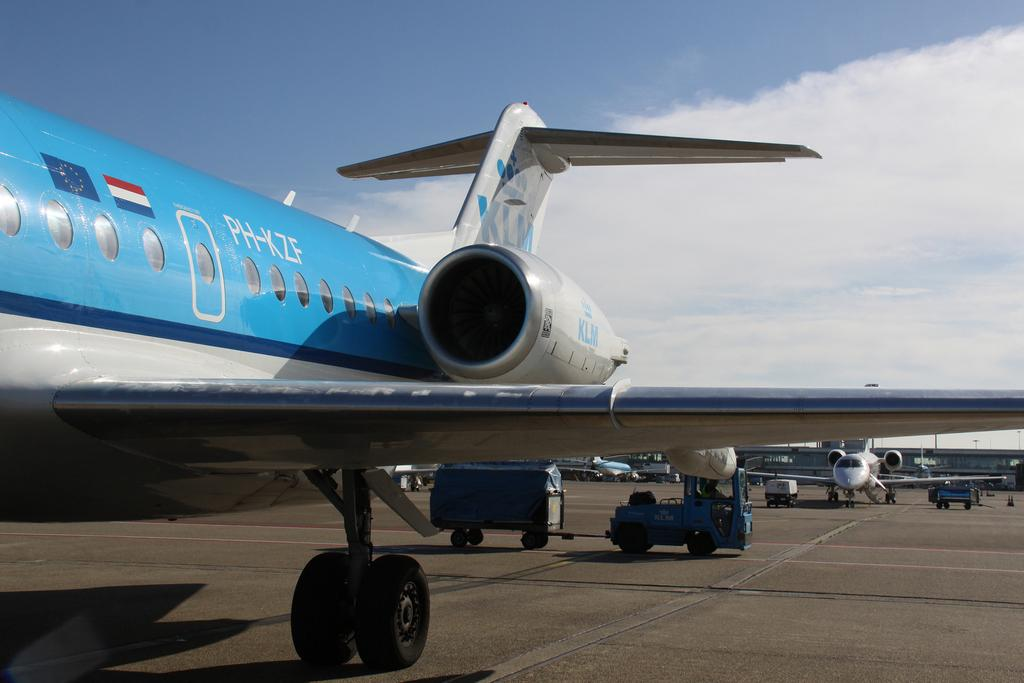<image>
Provide a brief description of the given image. A blue and silver passenger plane with the characters PH-KZF written on the side. 